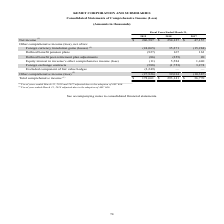From Kemet Corporation's financial document, Which years does the table provide information for the Consolidated Statements of Comprehensive Income (Loss)? The document contains multiple relevant values: 2019, 2018, 2017. From the document: "2019 2018 2017 2019 2018 2017 2019 2018 2017..." Also, What was the net income in 2017? According to the financial document, 47,157 (in thousands). The relevant text states: "Net income (1) $ 206,587 $ 254,127 $ 47,157..." Also, What was the Defined benefit pension plans in 2019? According to the financial document, (927) (in thousands). The relevant text states: "Defined benefit pension plans (927) 167 163..." Also, How many years did net income exceed $100,000 thousand? Counting the relevant items in the document: 2019, 2018, I find 2 instances. The key data points involved are: 2018, 2019. Also, can you calculate: What was the change in Defined benefit post-retirement plan adjustments between 2017 and 2019? Based on the calculation: -86-20, the result is -106 (in thousands). This is based on the information: "Defined benefit post-retirement plan adjustments (86) (255) 20 nefit post-retirement plan adjustments (86) (255) 20..." The key data points involved are: 20, 86. Also, can you calculate: What was the percentage change in the Total comprehensive income between 2018 and 2019? To answer this question, I need to perform calculations using the financial data. The calculation is: (178,661-293,141)/293,141, which equals -39.05 (percentage). This is based on the information: "Total comprehensive income (1) $ 178,661 $ 293,141 $ 36,770 Total comprehensive income (1) $ 178,661 $ 293,141 $ 36,770..." The key data points involved are: 178,661, 293,141. 